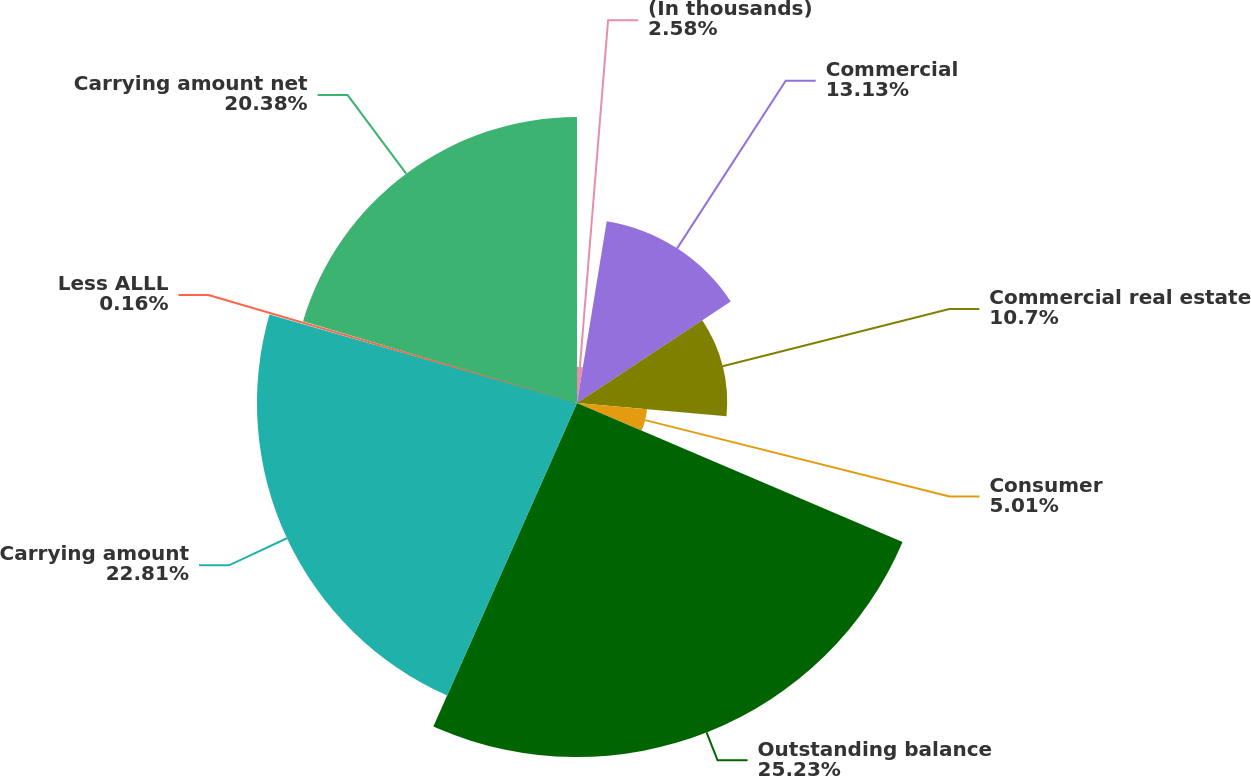<chart> <loc_0><loc_0><loc_500><loc_500><pie_chart><fcel>(In thousands)<fcel>Commercial<fcel>Commercial real estate<fcel>Consumer<fcel>Outstanding balance<fcel>Carrying amount<fcel>Less ALLL<fcel>Carrying amount net<nl><fcel>2.58%<fcel>13.13%<fcel>10.7%<fcel>5.01%<fcel>25.23%<fcel>22.81%<fcel>0.16%<fcel>20.38%<nl></chart> 